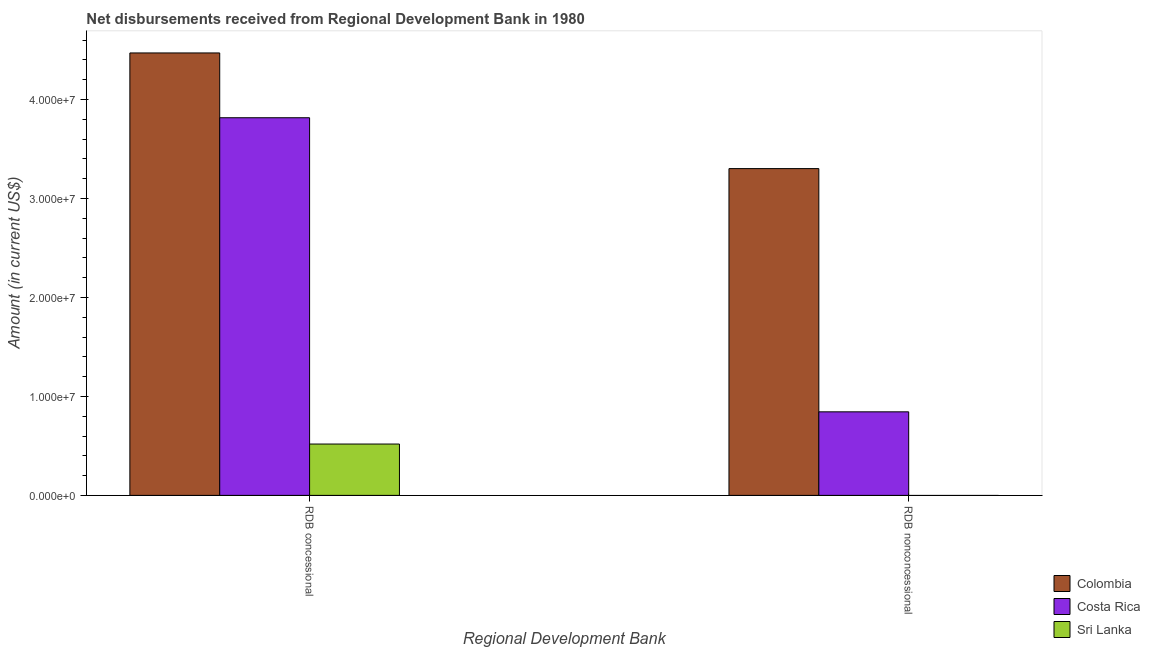How many groups of bars are there?
Give a very brief answer. 2. What is the label of the 2nd group of bars from the left?
Your answer should be compact. RDB nonconcessional. What is the net non concessional disbursements from rdb in Sri Lanka?
Your answer should be compact. 0. Across all countries, what is the maximum net non concessional disbursements from rdb?
Provide a succinct answer. 3.30e+07. Across all countries, what is the minimum net non concessional disbursements from rdb?
Keep it short and to the point. 0. What is the total net non concessional disbursements from rdb in the graph?
Give a very brief answer. 4.15e+07. What is the difference between the net non concessional disbursements from rdb in Colombia and that in Costa Rica?
Ensure brevity in your answer.  2.46e+07. What is the difference between the net non concessional disbursements from rdb in Colombia and the net concessional disbursements from rdb in Sri Lanka?
Make the answer very short. 2.78e+07. What is the average net non concessional disbursements from rdb per country?
Provide a succinct answer. 1.38e+07. What is the difference between the net concessional disbursements from rdb and net non concessional disbursements from rdb in Colombia?
Your answer should be very brief. 1.17e+07. In how many countries, is the net non concessional disbursements from rdb greater than 18000000 US$?
Your response must be concise. 1. What is the ratio of the net concessional disbursements from rdb in Costa Rica to that in Colombia?
Offer a very short reply. 0.85. In how many countries, is the net concessional disbursements from rdb greater than the average net concessional disbursements from rdb taken over all countries?
Keep it short and to the point. 2. What is the difference between two consecutive major ticks on the Y-axis?
Your response must be concise. 1.00e+07. Where does the legend appear in the graph?
Make the answer very short. Bottom right. How are the legend labels stacked?
Keep it short and to the point. Vertical. What is the title of the graph?
Offer a very short reply. Net disbursements received from Regional Development Bank in 1980. What is the label or title of the X-axis?
Offer a very short reply. Regional Development Bank. What is the label or title of the Y-axis?
Provide a short and direct response. Amount (in current US$). What is the Amount (in current US$) in Colombia in RDB concessional?
Ensure brevity in your answer.  4.47e+07. What is the Amount (in current US$) of Costa Rica in RDB concessional?
Your response must be concise. 3.82e+07. What is the Amount (in current US$) of Sri Lanka in RDB concessional?
Ensure brevity in your answer.  5.19e+06. What is the Amount (in current US$) of Colombia in RDB nonconcessional?
Your answer should be very brief. 3.30e+07. What is the Amount (in current US$) in Costa Rica in RDB nonconcessional?
Make the answer very short. 8.44e+06. What is the Amount (in current US$) in Sri Lanka in RDB nonconcessional?
Offer a very short reply. 0. Across all Regional Development Bank, what is the maximum Amount (in current US$) in Colombia?
Keep it short and to the point. 4.47e+07. Across all Regional Development Bank, what is the maximum Amount (in current US$) of Costa Rica?
Your response must be concise. 3.82e+07. Across all Regional Development Bank, what is the maximum Amount (in current US$) in Sri Lanka?
Your answer should be very brief. 5.19e+06. Across all Regional Development Bank, what is the minimum Amount (in current US$) of Colombia?
Your answer should be very brief. 3.30e+07. Across all Regional Development Bank, what is the minimum Amount (in current US$) in Costa Rica?
Provide a short and direct response. 8.44e+06. Across all Regional Development Bank, what is the minimum Amount (in current US$) in Sri Lanka?
Give a very brief answer. 0. What is the total Amount (in current US$) in Colombia in the graph?
Ensure brevity in your answer.  7.77e+07. What is the total Amount (in current US$) in Costa Rica in the graph?
Give a very brief answer. 4.66e+07. What is the total Amount (in current US$) of Sri Lanka in the graph?
Offer a very short reply. 5.19e+06. What is the difference between the Amount (in current US$) of Colombia in RDB concessional and that in RDB nonconcessional?
Your response must be concise. 1.17e+07. What is the difference between the Amount (in current US$) in Costa Rica in RDB concessional and that in RDB nonconcessional?
Provide a short and direct response. 2.97e+07. What is the difference between the Amount (in current US$) in Colombia in RDB concessional and the Amount (in current US$) in Costa Rica in RDB nonconcessional?
Offer a terse response. 3.63e+07. What is the average Amount (in current US$) in Colombia per Regional Development Bank?
Provide a succinct answer. 3.89e+07. What is the average Amount (in current US$) in Costa Rica per Regional Development Bank?
Offer a very short reply. 2.33e+07. What is the average Amount (in current US$) of Sri Lanka per Regional Development Bank?
Ensure brevity in your answer.  2.59e+06. What is the difference between the Amount (in current US$) of Colombia and Amount (in current US$) of Costa Rica in RDB concessional?
Provide a succinct answer. 6.55e+06. What is the difference between the Amount (in current US$) in Colombia and Amount (in current US$) in Sri Lanka in RDB concessional?
Offer a terse response. 3.95e+07. What is the difference between the Amount (in current US$) of Costa Rica and Amount (in current US$) of Sri Lanka in RDB concessional?
Your answer should be very brief. 3.30e+07. What is the difference between the Amount (in current US$) of Colombia and Amount (in current US$) of Costa Rica in RDB nonconcessional?
Your answer should be compact. 2.46e+07. What is the ratio of the Amount (in current US$) of Colombia in RDB concessional to that in RDB nonconcessional?
Your response must be concise. 1.35. What is the ratio of the Amount (in current US$) in Costa Rica in RDB concessional to that in RDB nonconcessional?
Your answer should be very brief. 4.52. What is the difference between the highest and the second highest Amount (in current US$) in Colombia?
Keep it short and to the point. 1.17e+07. What is the difference between the highest and the second highest Amount (in current US$) in Costa Rica?
Your answer should be compact. 2.97e+07. What is the difference between the highest and the lowest Amount (in current US$) of Colombia?
Your answer should be compact. 1.17e+07. What is the difference between the highest and the lowest Amount (in current US$) in Costa Rica?
Your answer should be compact. 2.97e+07. What is the difference between the highest and the lowest Amount (in current US$) of Sri Lanka?
Keep it short and to the point. 5.19e+06. 